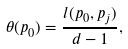Convert formula to latex. <formula><loc_0><loc_0><loc_500><loc_500>\theta ( p _ { 0 } ) = \frac { l ( p _ { 0 } , p _ { j } ) } { d - 1 } ,</formula> 